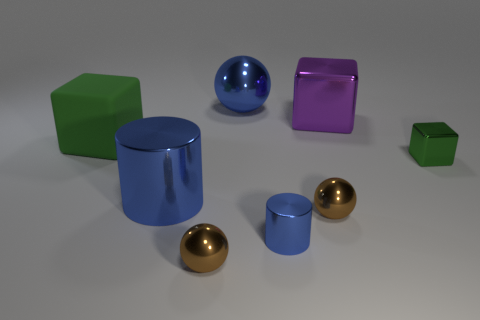The green thing that is made of the same material as the tiny blue cylinder is what shape?
Ensure brevity in your answer.  Cube. Are there any big purple blocks on the left side of the small green metallic block?
Give a very brief answer. Yes. Are there fewer big objects in front of the big purple metal block than small gray matte cylinders?
Your answer should be compact. No. What is the material of the big blue cylinder?
Offer a terse response. Metal. What is the color of the large metallic block?
Give a very brief answer. Purple. The metallic sphere that is both to the left of the tiny shiny cylinder and behind the small blue object is what color?
Give a very brief answer. Blue. Is there any other thing that is the same material as the large green object?
Provide a succinct answer. No. Are the big blue ball and the block that is behind the matte object made of the same material?
Make the answer very short. Yes. There is a cube right of the large purple cube that is to the right of the green rubber cube; what is its size?
Offer a very short reply. Small. Is there anything else of the same color as the small metal cube?
Give a very brief answer. Yes. 